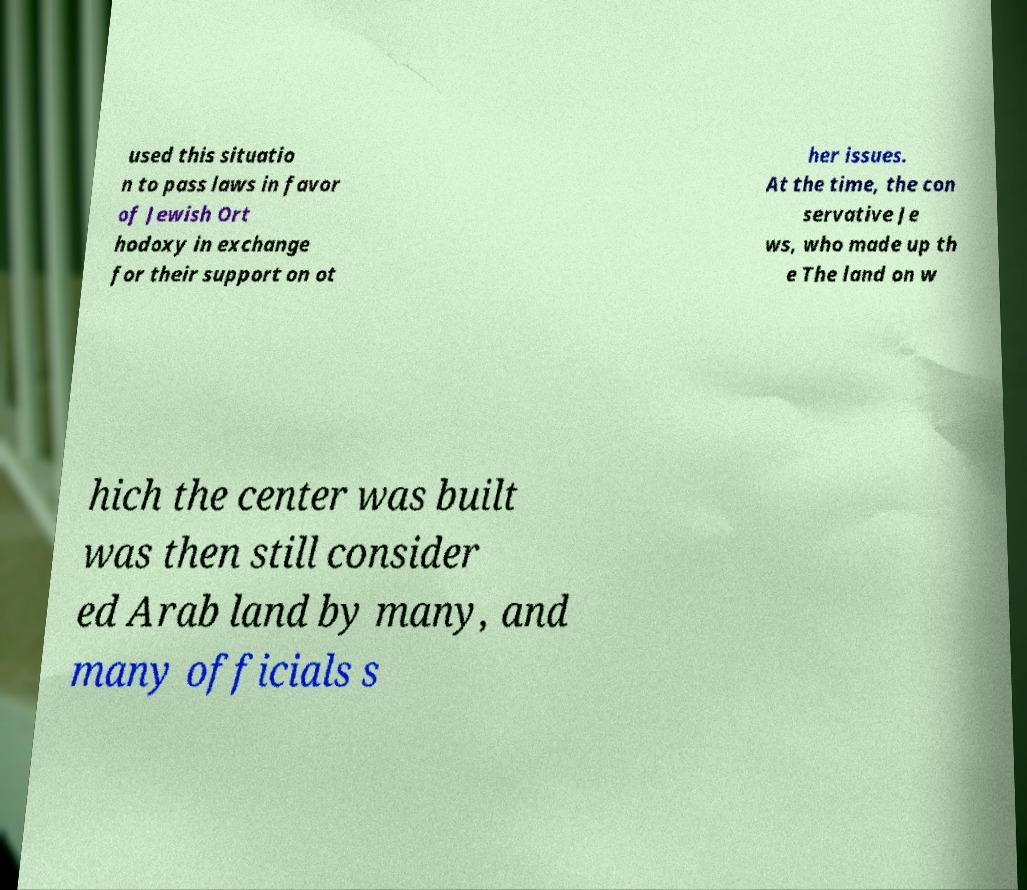There's text embedded in this image that I need extracted. Can you transcribe it verbatim? used this situatio n to pass laws in favor of Jewish Ort hodoxy in exchange for their support on ot her issues. At the time, the con servative Je ws, who made up th e The land on w hich the center was built was then still consider ed Arab land by many, and many officials s 